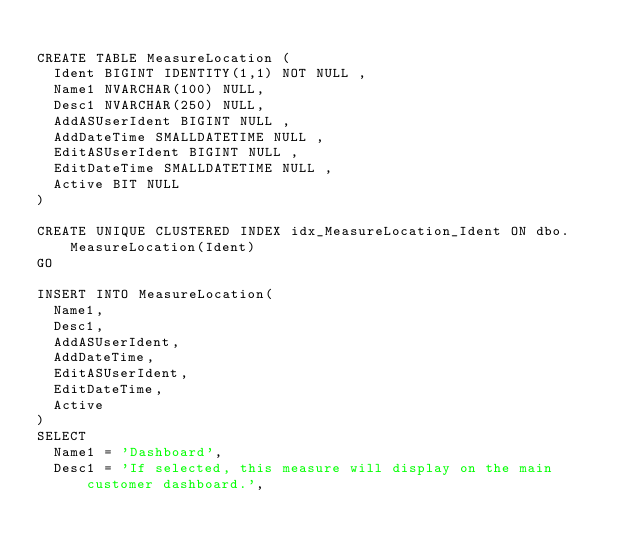<code> <loc_0><loc_0><loc_500><loc_500><_SQL_>
CREATE TABLE MeasureLocation (
	Ident BIGINT IDENTITY(1,1) NOT NULL ,
	Name1 NVARCHAR(100) NULL,
	Desc1 NVARCHAR(250) NULL,
	AddASUserIdent BIGINT NULL ,
	AddDateTime SMALLDATETIME NULL ,
	EditASUserIdent BIGINT NULL ,	
	EditDateTime SMALLDATETIME NULL ,
	Active BIT NULL
)

CREATE UNIQUE CLUSTERED INDEX idx_MeasureLocation_Ident ON dbo.MeasureLocation(Ident) 
GO

INSERT INTO MeasureLocation(
	Name1,
	Desc1,
	AddASUserIdent,
	AddDateTime,
	EditASUserIdent,
	EditDateTime,
	Active
)
SELECT
	Name1 = 'Dashboard',
	Desc1 = 'If selected, this measure will display on the main customer dashboard.',</code> 